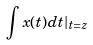Convert formula to latex. <formula><loc_0><loc_0><loc_500><loc_500>\int x ( t ) d t | _ { t = z }</formula> 